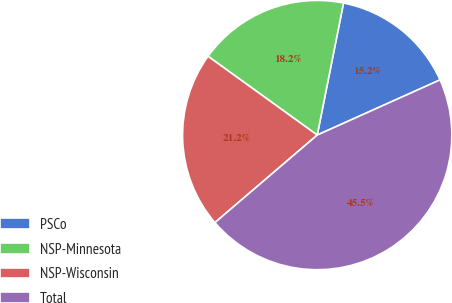Convert chart. <chart><loc_0><loc_0><loc_500><loc_500><pie_chart><fcel>PSCo<fcel>NSP-Minnesota<fcel>NSP-Wisconsin<fcel>Total<nl><fcel>15.15%<fcel>18.18%<fcel>21.21%<fcel>45.45%<nl></chart> 